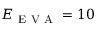<formula> <loc_0><loc_0><loc_500><loc_500>E _ { E V A } = 1 0</formula> 